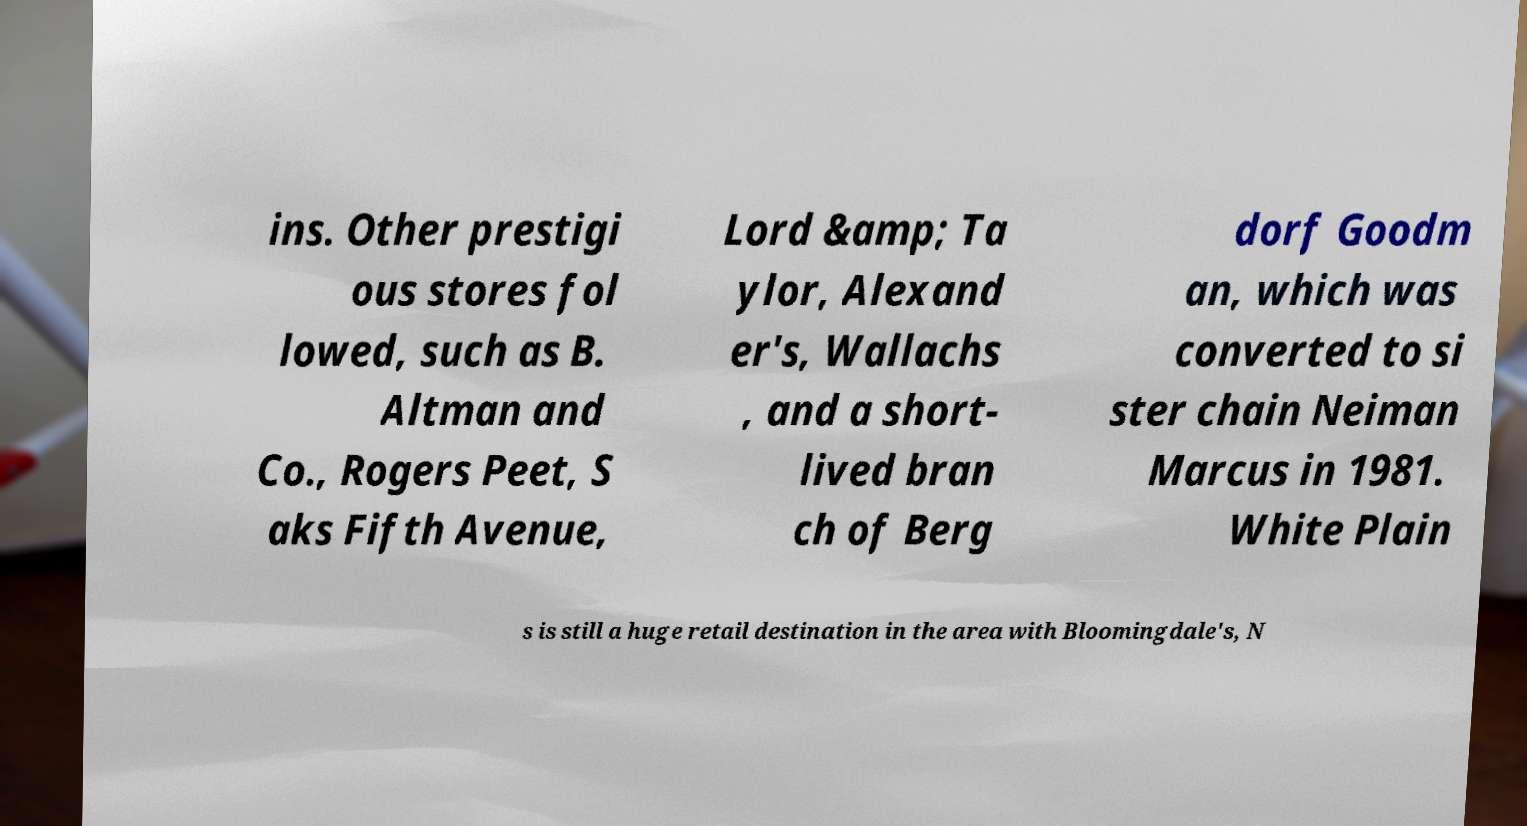Could you extract and type out the text from this image? ins. Other prestigi ous stores fol lowed, such as B. Altman and Co., Rogers Peet, S aks Fifth Avenue, Lord &amp; Ta ylor, Alexand er's, Wallachs , and a short- lived bran ch of Berg dorf Goodm an, which was converted to si ster chain Neiman Marcus in 1981. White Plain s is still a huge retail destination in the area with Bloomingdale's, N 